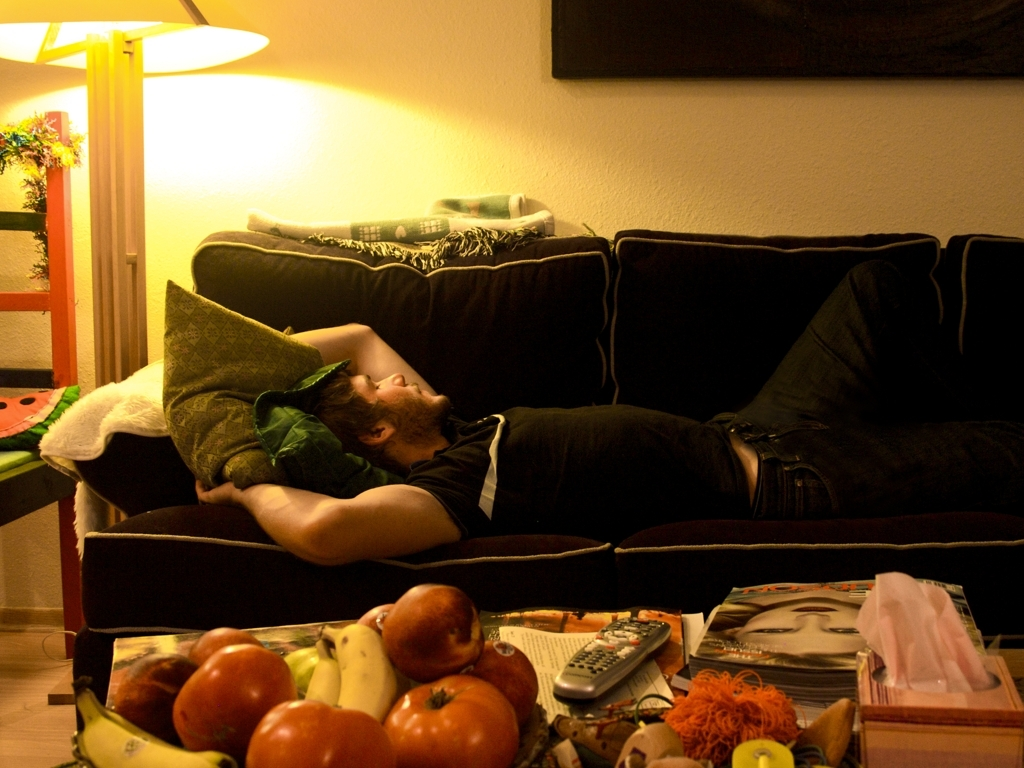Can you tell me what objects are visible on the coffee table? The coffee table is strewn with various objects, including fruits like bananas and apples, a remote control, magazines, and a toy, which gives the setting a lived-in, authentic vibe. 